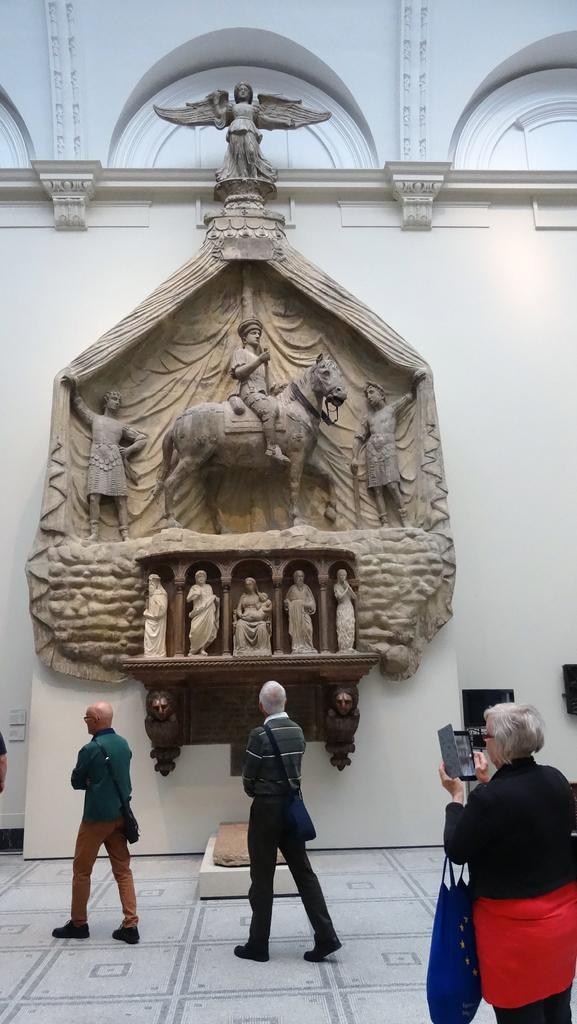Please provide a concise description of this image. This image consists of three people walking. At the bottom, there is a floor. In the background, there is a wall along with wooden art and sculptures. 